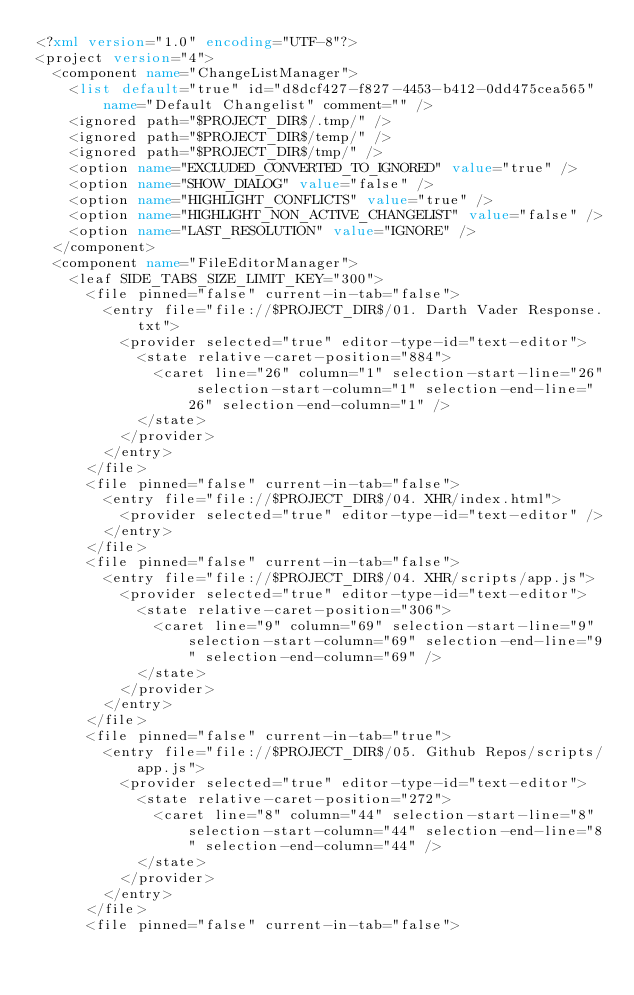Convert code to text. <code><loc_0><loc_0><loc_500><loc_500><_XML_><?xml version="1.0" encoding="UTF-8"?>
<project version="4">
  <component name="ChangeListManager">
    <list default="true" id="d8dcf427-f827-4453-b412-0dd475cea565" name="Default Changelist" comment="" />
    <ignored path="$PROJECT_DIR$/.tmp/" />
    <ignored path="$PROJECT_DIR$/temp/" />
    <ignored path="$PROJECT_DIR$/tmp/" />
    <option name="EXCLUDED_CONVERTED_TO_IGNORED" value="true" />
    <option name="SHOW_DIALOG" value="false" />
    <option name="HIGHLIGHT_CONFLICTS" value="true" />
    <option name="HIGHLIGHT_NON_ACTIVE_CHANGELIST" value="false" />
    <option name="LAST_RESOLUTION" value="IGNORE" />
  </component>
  <component name="FileEditorManager">
    <leaf SIDE_TABS_SIZE_LIMIT_KEY="300">
      <file pinned="false" current-in-tab="false">
        <entry file="file://$PROJECT_DIR$/01. Darth Vader Response.txt">
          <provider selected="true" editor-type-id="text-editor">
            <state relative-caret-position="884">
              <caret line="26" column="1" selection-start-line="26" selection-start-column="1" selection-end-line="26" selection-end-column="1" />
            </state>
          </provider>
        </entry>
      </file>
      <file pinned="false" current-in-tab="false">
        <entry file="file://$PROJECT_DIR$/04. XHR/index.html">
          <provider selected="true" editor-type-id="text-editor" />
        </entry>
      </file>
      <file pinned="false" current-in-tab="false">
        <entry file="file://$PROJECT_DIR$/04. XHR/scripts/app.js">
          <provider selected="true" editor-type-id="text-editor">
            <state relative-caret-position="306">
              <caret line="9" column="69" selection-start-line="9" selection-start-column="69" selection-end-line="9" selection-end-column="69" />
            </state>
          </provider>
        </entry>
      </file>
      <file pinned="false" current-in-tab="true">
        <entry file="file://$PROJECT_DIR$/05. Github Repos/scripts/app.js">
          <provider selected="true" editor-type-id="text-editor">
            <state relative-caret-position="272">
              <caret line="8" column="44" selection-start-line="8" selection-start-column="44" selection-end-line="8" selection-end-column="44" />
            </state>
          </provider>
        </entry>
      </file>
      <file pinned="false" current-in-tab="false"></code> 